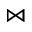<formula> <loc_0><loc_0><loc_500><loc_500>\bowtie</formula> 